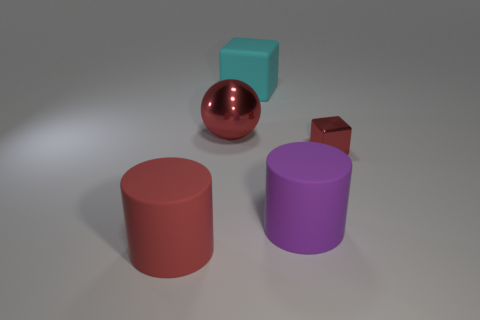Subtract all spheres. How many objects are left? 4 Add 2 big brown metal things. How many objects exist? 7 Subtract all purple objects. Subtract all big red matte cylinders. How many objects are left? 3 Add 4 purple things. How many purple things are left? 5 Add 2 big rubber cubes. How many big rubber cubes exist? 3 Subtract 0 green balls. How many objects are left? 5 